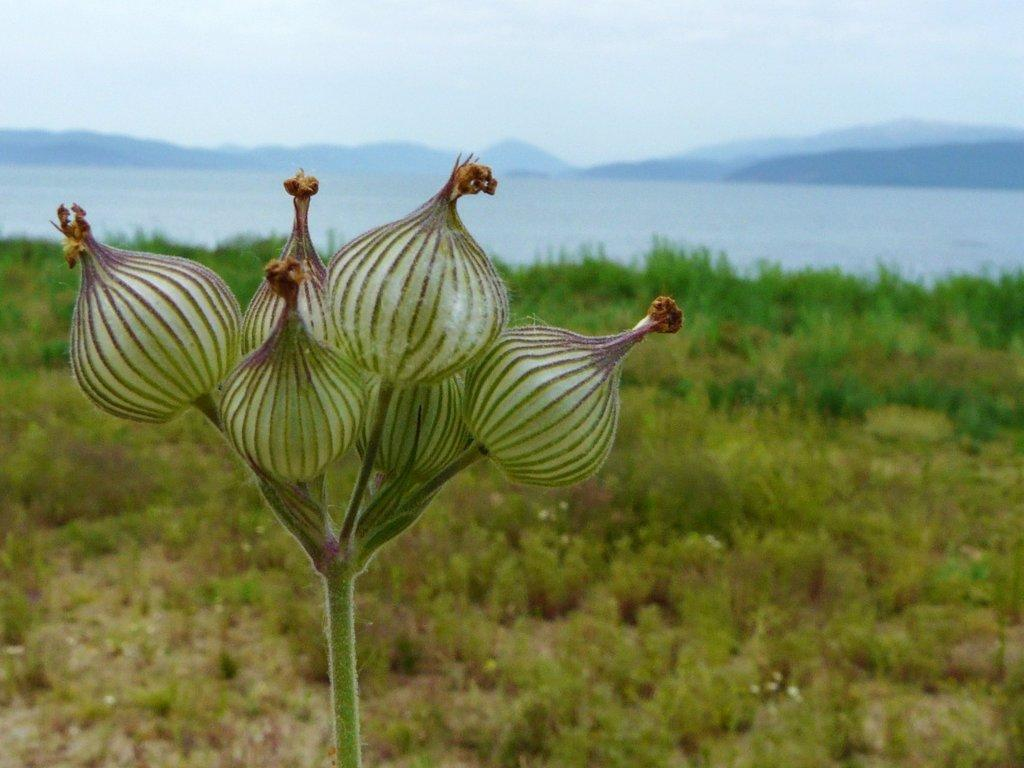What type of living organisms can be seen in the image? Plants are visible in the image. What can be seen in the background of the image? Water, mountains, and the sky are visible in the background of the image. How is the background of the image depicted? The background of the image is blurred. What type of history lesson is being taught in the image? There is no indication of a history lesson in the image. 